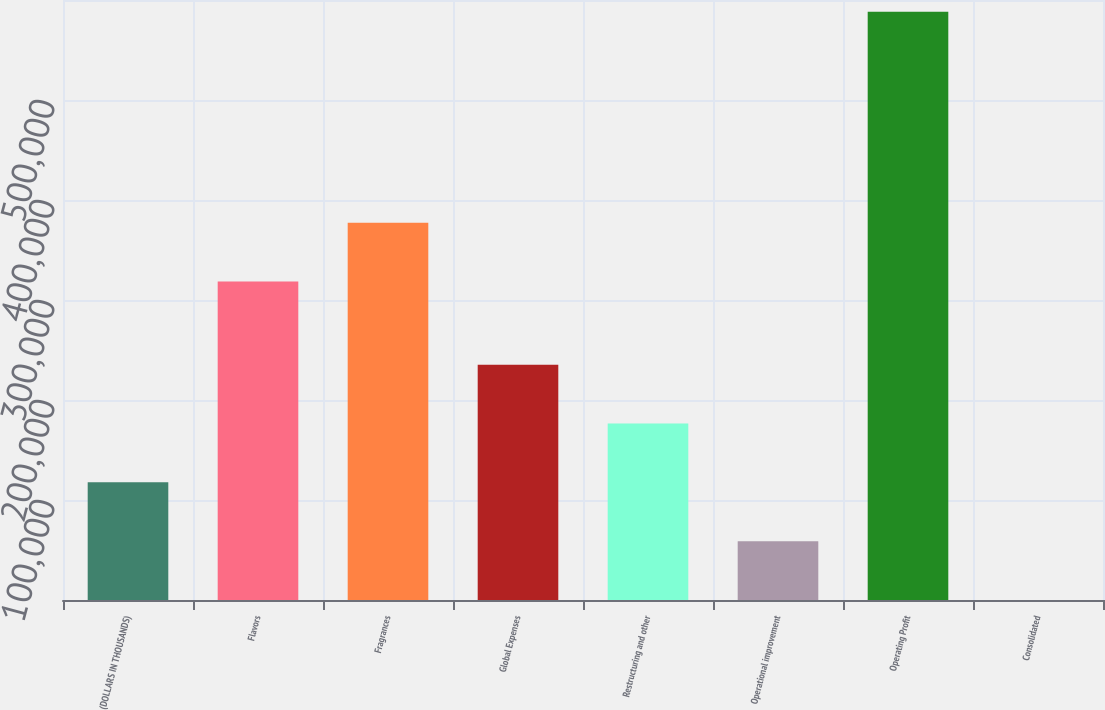Convert chart to OTSL. <chart><loc_0><loc_0><loc_500><loc_500><bar_chart><fcel>(DOLLARS IN THOUSANDS)<fcel>Flavors<fcel>Fragrances<fcel>Global Expenses<fcel>Restructuring and other<fcel>Operational improvement<fcel>Operating Profit<fcel>Consolidated<nl><fcel>117685<fcel>318476<fcel>377309<fcel>235350<fcel>176518<fcel>58852.2<fcel>588347<fcel>19.5<nl></chart> 